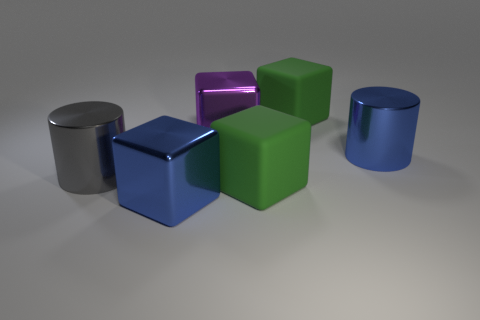Subtract all blue shiny blocks. How many blocks are left? 3 Subtract all cubes. How many objects are left? 2 Subtract all blue blocks. How many blocks are left? 3 Add 3 green rubber spheres. How many objects exist? 9 Subtract 0 cyan blocks. How many objects are left? 6 Subtract 2 cylinders. How many cylinders are left? 0 Subtract all gray cylinders. Subtract all blue blocks. How many cylinders are left? 1 Subtract all brown blocks. How many blue cylinders are left? 1 Subtract all big blue metal cubes. Subtract all gray metal objects. How many objects are left? 4 Add 6 cubes. How many cubes are left? 10 